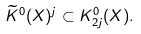Convert formula to latex. <formula><loc_0><loc_0><loc_500><loc_500>\widetilde { K } ^ { 0 } ( X ) ^ { j } \subset K ^ { 0 } _ { 2 j } ( X ) .</formula> 